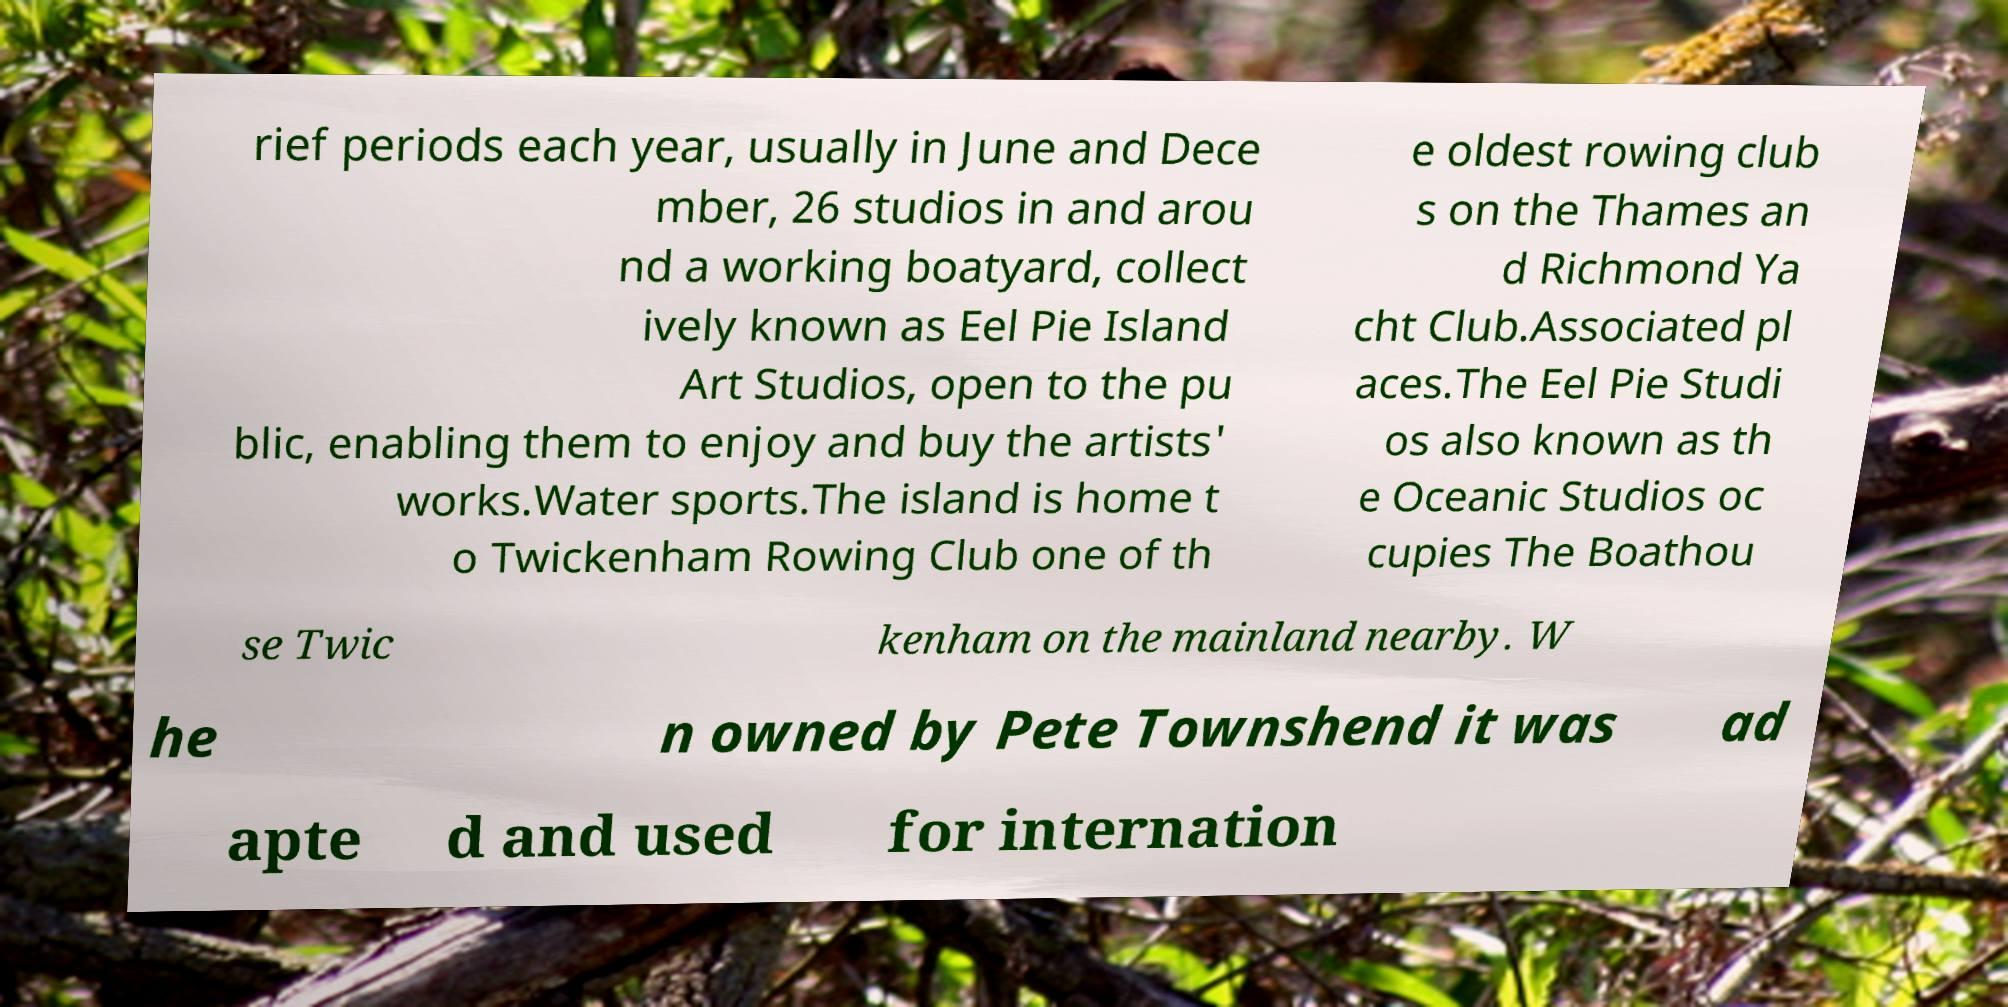Can you accurately transcribe the text from the provided image for me? rief periods each year, usually in June and Dece mber, 26 studios in and arou nd a working boatyard, collect ively known as Eel Pie Island Art Studios, open to the pu blic, enabling them to enjoy and buy the artists' works.Water sports.The island is home t o Twickenham Rowing Club one of th e oldest rowing club s on the Thames an d Richmond Ya cht Club.Associated pl aces.The Eel Pie Studi os also known as th e Oceanic Studios oc cupies The Boathou se Twic kenham on the mainland nearby. W he n owned by Pete Townshend it was ad apte d and used for internation 